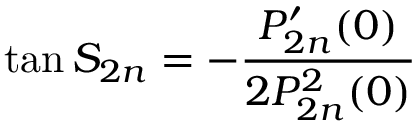<formula> <loc_0><loc_0><loc_500><loc_500>\tan S _ { 2 n } = - \frac { P _ { 2 n } ^ { \prime } ( 0 ) } { 2 P _ { 2 n } ^ { 2 } ( 0 ) }</formula> 